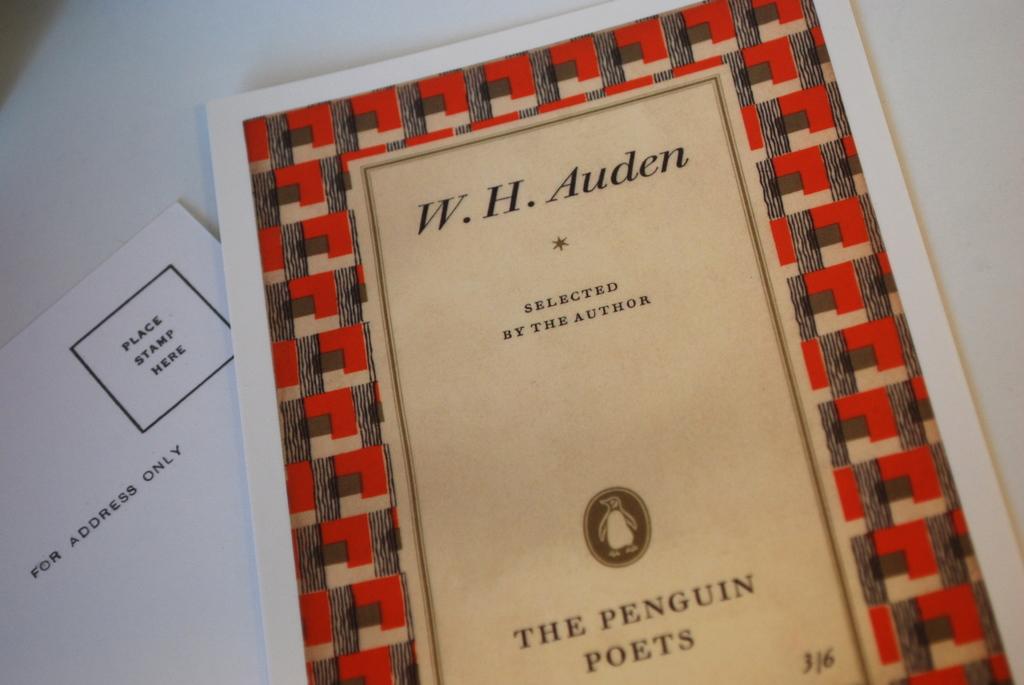Who wrote this book?
Provide a short and direct response. W.h. auden. Which type of book?
Make the answer very short. Poetry. 